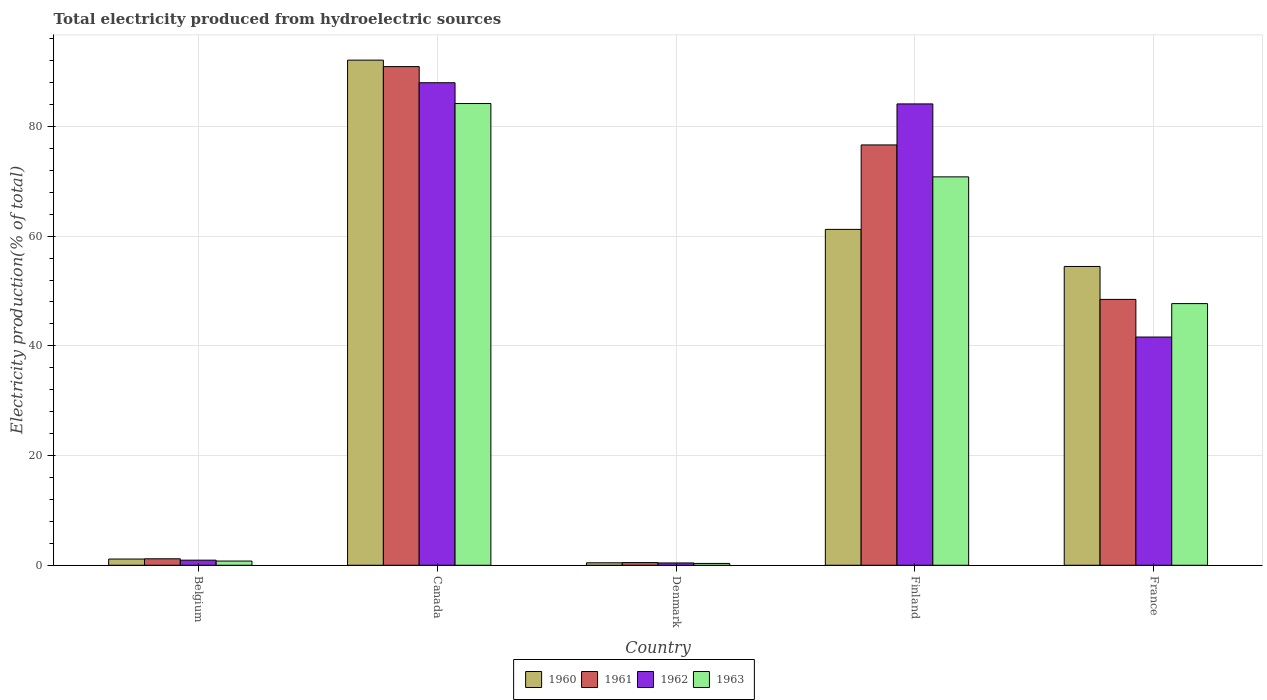How many different coloured bars are there?
Provide a succinct answer. 4. How many groups of bars are there?
Offer a terse response. 5. How many bars are there on the 1st tick from the left?
Offer a terse response. 4. How many bars are there on the 2nd tick from the right?
Offer a very short reply. 4. What is the total electricity produced in 1960 in Belgium?
Give a very brief answer. 1.14. Across all countries, what is the maximum total electricity produced in 1960?
Provide a short and direct response. 92.09. Across all countries, what is the minimum total electricity produced in 1962?
Keep it short and to the point. 0.42. In which country was the total electricity produced in 1960 maximum?
Provide a succinct answer. Canada. What is the total total electricity produced in 1960 in the graph?
Keep it short and to the point. 209.38. What is the difference between the total electricity produced in 1960 in Finland and that in France?
Make the answer very short. 6.76. What is the difference between the total electricity produced in 1963 in Belgium and the total electricity produced in 1962 in Finland?
Offer a very short reply. -83.34. What is the average total electricity produced in 1961 per country?
Ensure brevity in your answer.  43.53. What is the difference between the total electricity produced of/in 1962 and total electricity produced of/in 1963 in Belgium?
Provide a succinct answer. 0.16. What is the ratio of the total electricity produced in 1960 in Denmark to that in Finland?
Your answer should be compact. 0.01. Is the total electricity produced in 1961 in Belgium less than that in Denmark?
Provide a succinct answer. No. Is the difference between the total electricity produced in 1962 in Belgium and Finland greater than the difference between the total electricity produced in 1963 in Belgium and Finland?
Your response must be concise. No. What is the difference between the highest and the second highest total electricity produced in 1960?
Your answer should be compact. 30.86. What is the difference between the highest and the lowest total electricity produced in 1960?
Provide a short and direct response. 91.64. In how many countries, is the total electricity produced in 1960 greater than the average total electricity produced in 1960 taken over all countries?
Make the answer very short. 3. What does the 1st bar from the right in Finland represents?
Provide a succinct answer. 1963. Is it the case that in every country, the sum of the total electricity produced in 1962 and total electricity produced in 1963 is greater than the total electricity produced in 1960?
Your answer should be compact. Yes. How many bars are there?
Provide a succinct answer. 20. How many countries are there in the graph?
Your answer should be very brief. 5. What is the difference between two consecutive major ticks on the Y-axis?
Offer a terse response. 20. Are the values on the major ticks of Y-axis written in scientific E-notation?
Provide a short and direct response. No. Does the graph contain grids?
Your answer should be compact. Yes. Where does the legend appear in the graph?
Ensure brevity in your answer.  Bottom center. What is the title of the graph?
Your answer should be very brief. Total electricity produced from hydroelectric sources. Does "1966" appear as one of the legend labels in the graph?
Offer a terse response. No. What is the Electricity production(% of total) of 1960 in Belgium?
Provide a short and direct response. 1.14. What is the Electricity production(% of total) in 1961 in Belgium?
Keep it short and to the point. 1.18. What is the Electricity production(% of total) of 1962 in Belgium?
Keep it short and to the point. 0.93. What is the Electricity production(% of total) of 1963 in Belgium?
Ensure brevity in your answer.  0.77. What is the Electricity production(% of total) in 1960 in Canada?
Provide a succinct answer. 92.09. What is the Electricity production(% of total) in 1961 in Canada?
Provide a succinct answer. 90.91. What is the Electricity production(% of total) in 1962 in Canada?
Your answer should be very brief. 87.97. What is the Electricity production(% of total) in 1963 in Canada?
Provide a succinct answer. 84.18. What is the Electricity production(% of total) of 1960 in Denmark?
Make the answer very short. 0.45. What is the Electricity production(% of total) of 1961 in Denmark?
Give a very brief answer. 0.49. What is the Electricity production(% of total) in 1962 in Denmark?
Give a very brief answer. 0.42. What is the Electricity production(% of total) of 1963 in Denmark?
Keep it short and to the point. 0.33. What is the Electricity production(% of total) in 1960 in Finland?
Give a very brief answer. 61.23. What is the Electricity production(% of total) in 1961 in Finland?
Your answer should be very brief. 76.63. What is the Electricity production(% of total) of 1962 in Finland?
Offer a very short reply. 84.11. What is the Electricity production(% of total) of 1963 in Finland?
Give a very brief answer. 70.81. What is the Electricity production(% of total) in 1960 in France?
Provide a short and direct response. 54.47. What is the Electricity production(% of total) in 1961 in France?
Your answer should be compact. 48.47. What is the Electricity production(% of total) in 1962 in France?
Ensure brevity in your answer.  41.61. What is the Electricity production(% of total) in 1963 in France?
Your response must be concise. 47.7. Across all countries, what is the maximum Electricity production(% of total) of 1960?
Your response must be concise. 92.09. Across all countries, what is the maximum Electricity production(% of total) of 1961?
Ensure brevity in your answer.  90.91. Across all countries, what is the maximum Electricity production(% of total) of 1962?
Your response must be concise. 87.97. Across all countries, what is the maximum Electricity production(% of total) in 1963?
Make the answer very short. 84.18. Across all countries, what is the minimum Electricity production(% of total) of 1960?
Give a very brief answer. 0.45. Across all countries, what is the minimum Electricity production(% of total) in 1961?
Offer a terse response. 0.49. Across all countries, what is the minimum Electricity production(% of total) in 1962?
Provide a succinct answer. 0.42. Across all countries, what is the minimum Electricity production(% of total) of 1963?
Offer a very short reply. 0.33. What is the total Electricity production(% of total) of 1960 in the graph?
Provide a short and direct response. 209.38. What is the total Electricity production(% of total) of 1961 in the graph?
Offer a terse response. 217.67. What is the total Electricity production(% of total) of 1962 in the graph?
Give a very brief answer. 215.03. What is the total Electricity production(% of total) in 1963 in the graph?
Provide a succinct answer. 203.79. What is the difference between the Electricity production(% of total) in 1960 in Belgium and that in Canada?
Keep it short and to the point. -90.95. What is the difference between the Electricity production(% of total) in 1961 in Belgium and that in Canada?
Offer a terse response. -89.73. What is the difference between the Electricity production(% of total) of 1962 in Belgium and that in Canada?
Your answer should be compact. -87.04. What is the difference between the Electricity production(% of total) in 1963 in Belgium and that in Canada?
Your answer should be very brief. -83.41. What is the difference between the Electricity production(% of total) of 1960 in Belgium and that in Denmark?
Make the answer very short. 0.68. What is the difference between the Electricity production(% of total) of 1961 in Belgium and that in Denmark?
Keep it short and to the point. 0.69. What is the difference between the Electricity production(% of total) in 1962 in Belgium and that in Denmark?
Keep it short and to the point. 0.51. What is the difference between the Electricity production(% of total) of 1963 in Belgium and that in Denmark?
Your answer should be compact. 0.43. What is the difference between the Electricity production(% of total) of 1960 in Belgium and that in Finland?
Your answer should be compact. -60.1. What is the difference between the Electricity production(% of total) of 1961 in Belgium and that in Finland?
Give a very brief answer. -75.45. What is the difference between the Electricity production(% of total) in 1962 in Belgium and that in Finland?
Give a very brief answer. -83.18. What is the difference between the Electricity production(% of total) in 1963 in Belgium and that in Finland?
Your answer should be very brief. -70.04. What is the difference between the Electricity production(% of total) in 1960 in Belgium and that in France?
Keep it short and to the point. -53.34. What is the difference between the Electricity production(% of total) in 1961 in Belgium and that in France?
Offer a very short reply. -47.29. What is the difference between the Electricity production(% of total) in 1962 in Belgium and that in France?
Make the answer very short. -40.68. What is the difference between the Electricity production(% of total) of 1963 in Belgium and that in France?
Offer a very short reply. -46.94. What is the difference between the Electricity production(% of total) of 1960 in Canada and that in Denmark?
Your answer should be compact. 91.64. What is the difference between the Electricity production(% of total) in 1961 in Canada and that in Denmark?
Offer a very short reply. 90.42. What is the difference between the Electricity production(% of total) of 1962 in Canada and that in Denmark?
Your answer should be compact. 87.55. What is the difference between the Electricity production(% of total) in 1963 in Canada and that in Denmark?
Your response must be concise. 83.84. What is the difference between the Electricity production(% of total) of 1960 in Canada and that in Finland?
Your answer should be compact. 30.86. What is the difference between the Electricity production(% of total) in 1961 in Canada and that in Finland?
Give a very brief answer. 14.28. What is the difference between the Electricity production(% of total) in 1962 in Canada and that in Finland?
Your answer should be compact. 3.86. What is the difference between the Electricity production(% of total) of 1963 in Canada and that in Finland?
Offer a terse response. 13.37. What is the difference between the Electricity production(% of total) of 1960 in Canada and that in France?
Your response must be concise. 37.62. What is the difference between the Electricity production(% of total) of 1961 in Canada and that in France?
Make the answer very short. 42.44. What is the difference between the Electricity production(% of total) of 1962 in Canada and that in France?
Offer a terse response. 46.36. What is the difference between the Electricity production(% of total) of 1963 in Canada and that in France?
Give a very brief answer. 36.48. What is the difference between the Electricity production(% of total) of 1960 in Denmark and that in Finland?
Your answer should be very brief. -60.78. What is the difference between the Electricity production(% of total) in 1961 in Denmark and that in Finland?
Your answer should be compact. -76.14. What is the difference between the Electricity production(% of total) of 1962 in Denmark and that in Finland?
Provide a short and direct response. -83.69. What is the difference between the Electricity production(% of total) of 1963 in Denmark and that in Finland?
Ensure brevity in your answer.  -70.47. What is the difference between the Electricity production(% of total) in 1960 in Denmark and that in France?
Provide a short and direct response. -54.02. What is the difference between the Electricity production(% of total) of 1961 in Denmark and that in France?
Provide a short and direct response. -47.98. What is the difference between the Electricity production(% of total) of 1962 in Denmark and that in France?
Provide a succinct answer. -41.18. What is the difference between the Electricity production(% of total) in 1963 in Denmark and that in France?
Your answer should be very brief. -47.37. What is the difference between the Electricity production(% of total) of 1960 in Finland and that in France?
Provide a short and direct response. 6.76. What is the difference between the Electricity production(% of total) of 1961 in Finland and that in France?
Give a very brief answer. 28.16. What is the difference between the Electricity production(% of total) in 1962 in Finland and that in France?
Provide a short and direct response. 42.5. What is the difference between the Electricity production(% of total) in 1963 in Finland and that in France?
Keep it short and to the point. 23.11. What is the difference between the Electricity production(% of total) of 1960 in Belgium and the Electricity production(% of total) of 1961 in Canada?
Offer a very short reply. -89.78. What is the difference between the Electricity production(% of total) of 1960 in Belgium and the Electricity production(% of total) of 1962 in Canada?
Offer a very short reply. -86.83. What is the difference between the Electricity production(% of total) of 1960 in Belgium and the Electricity production(% of total) of 1963 in Canada?
Ensure brevity in your answer.  -83.04. What is the difference between the Electricity production(% of total) in 1961 in Belgium and the Electricity production(% of total) in 1962 in Canada?
Ensure brevity in your answer.  -86.79. What is the difference between the Electricity production(% of total) of 1961 in Belgium and the Electricity production(% of total) of 1963 in Canada?
Offer a terse response. -83. What is the difference between the Electricity production(% of total) of 1962 in Belgium and the Electricity production(% of total) of 1963 in Canada?
Your response must be concise. -83.25. What is the difference between the Electricity production(% of total) in 1960 in Belgium and the Electricity production(% of total) in 1961 in Denmark?
Your answer should be compact. 0.65. What is the difference between the Electricity production(% of total) in 1960 in Belgium and the Electricity production(% of total) in 1962 in Denmark?
Provide a short and direct response. 0.71. What is the difference between the Electricity production(% of total) in 1960 in Belgium and the Electricity production(% of total) in 1963 in Denmark?
Your response must be concise. 0.8. What is the difference between the Electricity production(% of total) of 1961 in Belgium and the Electricity production(% of total) of 1962 in Denmark?
Provide a succinct answer. 0.76. What is the difference between the Electricity production(% of total) of 1961 in Belgium and the Electricity production(% of total) of 1963 in Denmark?
Keep it short and to the point. 0.84. What is the difference between the Electricity production(% of total) of 1962 in Belgium and the Electricity production(% of total) of 1963 in Denmark?
Your answer should be very brief. 0.59. What is the difference between the Electricity production(% of total) in 1960 in Belgium and the Electricity production(% of total) in 1961 in Finland?
Keep it short and to the point. -75.49. What is the difference between the Electricity production(% of total) of 1960 in Belgium and the Electricity production(% of total) of 1962 in Finland?
Your answer should be compact. -82.97. What is the difference between the Electricity production(% of total) of 1960 in Belgium and the Electricity production(% of total) of 1963 in Finland?
Offer a terse response. -69.67. What is the difference between the Electricity production(% of total) in 1961 in Belgium and the Electricity production(% of total) in 1962 in Finland?
Your response must be concise. -82.93. What is the difference between the Electricity production(% of total) in 1961 in Belgium and the Electricity production(% of total) in 1963 in Finland?
Your answer should be compact. -69.63. What is the difference between the Electricity production(% of total) of 1962 in Belgium and the Electricity production(% of total) of 1963 in Finland?
Keep it short and to the point. -69.88. What is the difference between the Electricity production(% of total) of 1960 in Belgium and the Electricity production(% of total) of 1961 in France?
Make the answer very short. -47.33. What is the difference between the Electricity production(% of total) in 1960 in Belgium and the Electricity production(% of total) in 1962 in France?
Ensure brevity in your answer.  -40.47. What is the difference between the Electricity production(% of total) in 1960 in Belgium and the Electricity production(% of total) in 1963 in France?
Provide a succinct answer. -46.57. What is the difference between the Electricity production(% of total) of 1961 in Belgium and the Electricity production(% of total) of 1962 in France?
Ensure brevity in your answer.  -40.43. What is the difference between the Electricity production(% of total) in 1961 in Belgium and the Electricity production(% of total) in 1963 in France?
Make the answer very short. -46.52. What is the difference between the Electricity production(% of total) in 1962 in Belgium and the Electricity production(% of total) in 1963 in France?
Provide a succinct answer. -46.77. What is the difference between the Electricity production(% of total) of 1960 in Canada and the Electricity production(% of total) of 1961 in Denmark?
Your response must be concise. 91.6. What is the difference between the Electricity production(% of total) of 1960 in Canada and the Electricity production(% of total) of 1962 in Denmark?
Offer a terse response. 91.67. What is the difference between the Electricity production(% of total) of 1960 in Canada and the Electricity production(% of total) of 1963 in Denmark?
Your answer should be compact. 91.75. What is the difference between the Electricity production(% of total) of 1961 in Canada and the Electricity production(% of total) of 1962 in Denmark?
Ensure brevity in your answer.  90.49. What is the difference between the Electricity production(% of total) of 1961 in Canada and the Electricity production(% of total) of 1963 in Denmark?
Provide a succinct answer. 90.58. What is the difference between the Electricity production(% of total) in 1962 in Canada and the Electricity production(% of total) in 1963 in Denmark?
Ensure brevity in your answer.  87.63. What is the difference between the Electricity production(% of total) in 1960 in Canada and the Electricity production(% of total) in 1961 in Finland?
Your answer should be very brief. 15.46. What is the difference between the Electricity production(% of total) in 1960 in Canada and the Electricity production(% of total) in 1962 in Finland?
Provide a short and direct response. 7.98. What is the difference between the Electricity production(% of total) of 1960 in Canada and the Electricity production(% of total) of 1963 in Finland?
Provide a succinct answer. 21.28. What is the difference between the Electricity production(% of total) in 1961 in Canada and the Electricity production(% of total) in 1962 in Finland?
Your response must be concise. 6.8. What is the difference between the Electricity production(% of total) in 1961 in Canada and the Electricity production(% of total) in 1963 in Finland?
Offer a terse response. 20.1. What is the difference between the Electricity production(% of total) in 1962 in Canada and the Electricity production(% of total) in 1963 in Finland?
Provide a short and direct response. 17.16. What is the difference between the Electricity production(% of total) of 1960 in Canada and the Electricity production(% of total) of 1961 in France?
Offer a terse response. 43.62. What is the difference between the Electricity production(% of total) in 1960 in Canada and the Electricity production(% of total) in 1962 in France?
Your response must be concise. 50.48. What is the difference between the Electricity production(% of total) of 1960 in Canada and the Electricity production(% of total) of 1963 in France?
Your answer should be very brief. 44.39. What is the difference between the Electricity production(% of total) in 1961 in Canada and the Electricity production(% of total) in 1962 in France?
Give a very brief answer. 49.3. What is the difference between the Electricity production(% of total) in 1961 in Canada and the Electricity production(% of total) in 1963 in France?
Make the answer very short. 43.21. What is the difference between the Electricity production(% of total) in 1962 in Canada and the Electricity production(% of total) in 1963 in France?
Make the answer very short. 40.27. What is the difference between the Electricity production(% of total) of 1960 in Denmark and the Electricity production(% of total) of 1961 in Finland?
Provide a succinct answer. -76.18. What is the difference between the Electricity production(% of total) of 1960 in Denmark and the Electricity production(% of total) of 1962 in Finland?
Give a very brief answer. -83.66. What is the difference between the Electricity production(% of total) in 1960 in Denmark and the Electricity production(% of total) in 1963 in Finland?
Keep it short and to the point. -70.36. What is the difference between the Electricity production(% of total) in 1961 in Denmark and the Electricity production(% of total) in 1962 in Finland?
Give a very brief answer. -83.62. What is the difference between the Electricity production(% of total) of 1961 in Denmark and the Electricity production(% of total) of 1963 in Finland?
Your answer should be very brief. -70.32. What is the difference between the Electricity production(% of total) of 1962 in Denmark and the Electricity production(% of total) of 1963 in Finland?
Provide a succinct answer. -70.39. What is the difference between the Electricity production(% of total) in 1960 in Denmark and the Electricity production(% of total) in 1961 in France?
Give a very brief answer. -48.02. What is the difference between the Electricity production(% of total) of 1960 in Denmark and the Electricity production(% of total) of 1962 in France?
Make the answer very short. -41.15. What is the difference between the Electricity production(% of total) of 1960 in Denmark and the Electricity production(% of total) of 1963 in France?
Give a very brief answer. -47.25. What is the difference between the Electricity production(% of total) in 1961 in Denmark and the Electricity production(% of total) in 1962 in France?
Your answer should be compact. -41.12. What is the difference between the Electricity production(% of total) of 1961 in Denmark and the Electricity production(% of total) of 1963 in France?
Provide a short and direct response. -47.21. What is the difference between the Electricity production(% of total) of 1962 in Denmark and the Electricity production(% of total) of 1963 in France?
Provide a succinct answer. -47.28. What is the difference between the Electricity production(% of total) in 1960 in Finland and the Electricity production(% of total) in 1961 in France?
Keep it short and to the point. 12.76. What is the difference between the Electricity production(% of total) of 1960 in Finland and the Electricity production(% of total) of 1962 in France?
Provide a succinct answer. 19.63. What is the difference between the Electricity production(% of total) in 1960 in Finland and the Electricity production(% of total) in 1963 in France?
Your answer should be very brief. 13.53. What is the difference between the Electricity production(% of total) of 1961 in Finland and the Electricity production(% of total) of 1962 in France?
Ensure brevity in your answer.  35.02. What is the difference between the Electricity production(% of total) of 1961 in Finland and the Electricity production(% of total) of 1963 in France?
Provide a succinct answer. 28.93. What is the difference between the Electricity production(% of total) in 1962 in Finland and the Electricity production(% of total) in 1963 in France?
Offer a very short reply. 36.41. What is the average Electricity production(% of total) in 1960 per country?
Keep it short and to the point. 41.88. What is the average Electricity production(% of total) of 1961 per country?
Ensure brevity in your answer.  43.53. What is the average Electricity production(% of total) of 1962 per country?
Give a very brief answer. 43.01. What is the average Electricity production(% of total) in 1963 per country?
Ensure brevity in your answer.  40.76. What is the difference between the Electricity production(% of total) of 1960 and Electricity production(% of total) of 1961 in Belgium?
Your answer should be very brief. -0.04. What is the difference between the Electricity production(% of total) of 1960 and Electricity production(% of total) of 1962 in Belgium?
Give a very brief answer. 0.21. What is the difference between the Electricity production(% of total) of 1960 and Electricity production(% of total) of 1963 in Belgium?
Make the answer very short. 0.37. What is the difference between the Electricity production(% of total) in 1961 and Electricity production(% of total) in 1962 in Belgium?
Offer a terse response. 0.25. What is the difference between the Electricity production(% of total) in 1961 and Electricity production(% of total) in 1963 in Belgium?
Provide a short and direct response. 0.41. What is the difference between the Electricity production(% of total) in 1962 and Electricity production(% of total) in 1963 in Belgium?
Your answer should be compact. 0.16. What is the difference between the Electricity production(% of total) in 1960 and Electricity production(% of total) in 1961 in Canada?
Make the answer very short. 1.18. What is the difference between the Electricity production(% of total) in 1960 and Electricity production(% of total) in 1962 in Canada?
Offer a terse response. 4.12. What is the difference between the Electricity production(% of total) in 1960 and Electricity production(% of total) in 1963 in Canada?
Ensure brevity in your answer.  7.91. What is the difference between the Electricity production(% of total) in 1961 and Electricity production(% of total) in 1962 in Canada?
Provide a succinct answer. 2.94. What is the difference between the Electricity production(% of total) of 1961 and Electricity production(% of total) of 1963 in Canada?
Make the answer very short. 6.73. What is the difference between the Electricity production(% of total) of 1962 and Electricity production(% of total) of 1963 in Canada?
Your response must be concise. 3.79. What is the difference between the Electricity production(% of total) in 1960 and Electricity production(% of total) in 1961 in Denmark?
Give a very brief answer. -0.04. What is the difference between the Electricity production(% of total) of 1960 and Electricity production(% of total) of 1962 in Denmark?
Give a very brief answer. 0.03. What is the difference between the Electricity production(% of total) in 1960 and Electricity production(% of total) in 1963 in Denmark?
Your response must be concise. 0.12. What is the difference between the Electricity production(% of total) of 1961 and Electricity production(% of total) of 1962 in Denmark?
Your answer should be compact. 0.07. What is the difference between the Electricity production(% of total) of 1961 and Electricity production(% of total) of 1963 in Denmark?
Give a very brief answer. 0.15. What is the difference between the Electricity production(% of total) in 1962 and Electricity production(% of total) in 1963 in Denmark?
Give a very brief answer. 0.09. What is the difference between the Electricity production(% of total) of 1960 and Electricity production(% of total) of 1961 in Finland?
Make the answer very short. -15.4. What is the difference between the Electricity production(% of total) in 1960 and Electricity production(% of total) in 1962 in Finland?
Offer a terse response. -22.88. What is the difference between the Electricity production(% of total) of 1960 and Electricity production(% of total) of 1963 in Finland?
Your answer should be compact. -9.58. What is the difference between the Electricity production(% of total) of 1961 and Electricity production(% of total) of 1962 in Finland?
Give a very brief answer. -7.48. What is the difference between the Electricity production(% of total) of 1961 and Electricity production(% of total) of 1963 in Finland?
Make the answer very short. 5.82. What is the difference between the Electricity production(% of total) in 1962 and Electricity production(% of total) in 1963 in Finland?
Give a very brief answer. 13.3. What is the difference between the Electricity production(% of total) of 1960 and Electricity production(% of total) of 1961 in France?
Give a very brief answer. 6.01. What is the difference between the Electricity production(% of total) in 1960 and Electricity production(% of total) in 1962 in France?
Give a very brief answer. 12.87. What is the difference between the Electricity production(% of total) in 1960 and Electricity production(% of total) in 1963 in France?
Provide a succinct answer. 6.77. What is the difference between the Electricity production(% of total) of 1961 and Electricity production(% of total) of 1962 in France?
Ensure brevity in your answer.  6.86. What is the difference between the Electricity production(% of total) in 1961 and Electricity production(% of total) in 1963 in France?
Your answer should be compact. 0.77. What is the difference between the Electricity production(% of total) of 1962 and Electricity production(% of total) of 1963 in France?
Your response must be concise. -6.1. What is the ratio of the Electricity production(% of total) of 1960 in Belgium to that in Canada?
Offer a very short reply. 0.01. What is the ratio of the Electricity production(% of total) of 1961 in Belgium to that in Canada?
Keep it short and to the point. 0.01. What is the ratio of the Electricity production(% of total) of 1962 in Belgium to that in Canada?
Give a very brief answer. 0.01. What is the ratio of the Electricity production(% of total) in 1963 in Belgium to that in Canada?
Your answer should be compact. 0.01. What is the ratio of the Electricity production(% of total) in 1960 in Belgium to that in Denmark?
Provide a short and direct response. 2.52. What is the ratio of the Electricity production(% of total) in 1961 in Belgium to that in Denmark?
Provide a short and direct response. 2.41. What is the ratio of the Electricity production(% of total) of 1962 in Belgium to that in Denmark?
Offer a very short reply. 2.21. What is the ratio of the Electricity production(% of total) of 1963 in Belgium to that in Denmark?
Provide a succinct answer. 2.29. What is the ratio of the Electricity production(% of total) in 1960 in Belgium to that in Finland?
Your response must be concise. 0.02. What is the ratio of the Electricity production(% of total) of 1961 in Belgium to that in Finland?
Make the answer very short. 0.02. What is the ratio of the Electricity production(% of total) of 1962 in Belgium to that in Finland?
Provide a short and direct response. 0.01. What is the ratio of the Electricity production(% of total) in 1963 in Belgium to that in Finland?
Give a very brief answer. 0.01. What is the ratio of the Electricity production(% of total) of 1960 in Belgium to that in France?
Your response must be concise. 0.02. What is the ratio of the Electricity production(% of total) of 1961 in Belgium to that in France?
Give a very brief answer. 0.02. What is the ratio of the Electricity production(% of total) in 1962 in Belgium to that in France?
Provide a succinct answer. 0.02. What is the ratio of the Electricity production(% of total) in 1963 in Belgium to that in France?
Provide a succinct answer. 0.02. What is the ratio of the Electricity production(% of total) in 1960 in Canada to that in Denmark?
Ensure brevity in your answer.  204.07. What is the ratio of the Electricity production(% of total) of 1961 in Canada to that in Denmark?
Ensure brevity in your answer.  185.88. What is the ratio of the Electricity production(% of total) in 1962 in Canada to that in Denmark?
Give a very brief answer. 208.99. What is the ratio of the Electricity production(% of total) of 1963 in Canada to that in Denmark?
Your answer should be compact. 251.69. What is the ratio of the Electricity production(% of total) in 1960 in Canada to that in Finland?
Your response must be concise. 1.5. What is the ratio of the Electricity production(% of total) of 1961 in Canada to that in Finland?
Provide a short and direct response. 1.19. What is the ratio of the Electricity production(% of total) in 1962 in Canada to that in Finland?
Offer a very short reply. 1.05. What is the ratio of the Electricity production(% of total) in 1963 in Canada to that in Finland?
Ensure brevity in your answer.  1.19. What is the ratio of the Electricity production(% of total) of 1960 in Canada to that in France?
Ensure brevity in your answer.  1.69. What is the ratio of the Electricity production(% of total) of 1961 in Canada to that in France?
Make the answer very short. 1.88. What is the ratio of the Electricity production(% of total) in 1962 in Canada to that in France?
Keep it short and to the point. 2.11. What is the ratio of the Electricity production(% of total) in 1963 in Canada to that in France?
Your response must be concise. 1.76. What is the ratio of the Electricity production(% of total) of 1960 in Denmark to that in Finland?
Give a very brief answer. 0.01. What is the ratio of the Electricity production(% of total) of 1961 in Denmark to that in Finland?
Make the answer very short. 0.01. What is the ratio of the Electricity production(% of total) of 1962 in Denmark to that in Finland?
Your response must be concise. 0.01. What is the ratio of the Electricity production(% of total) in 1963 in Denmark to that in Finland?
Your answer should be very brief. 0. What is the ratio of the Electricity production(% of total) in 1960 in Denmark to that in France?
Your response must be concise. 0.01. What is the ratio of the Electricity production(% of total) of 1961 in Denmark to that in France?
Your answer should be very brief. 0.01. What is the ratio of the Electricity production(% of total) of 1962 in Denmark to that in France?
Your answer should be very brief. 0.01. What is the ratio of the Electricity production(% of total) in 1963 in Denmark to that in France?
Ensure brevity in your answer.  0.01. What is the ratio of the Electricity production(% of total) in 1960 in Finland to that in France?
Offer a very short reply. 1.12. What is the ratio of the Electricity production(% of total) in 1961 in Finland to that in France?
Provide a succinct answer. 1.58. What is the ratio of the Electricity production(% of total) of 1962 in Finland to that in France?
Your answer should be very brief. 2.02. What is the ratio of the Electricity production(% of total) of 1963 in Finland to that in France?
Your answer should be very brief. 1.48. What is the difference between the highest and the second highest Electricity production(% of total) in 1960?
Provide a short and direct response. 30.86. What is the difference between the highest and the second highest Electricity production(% of total) in 1961?
Ensure brevity in your answer.  14.28. What is the difference between the highest and the second highest Electricity production(% of total) in 1962?
Your response must be concise. 3.86. What is the difference between the highest and the second highest Electricity production(% of total) in 1963?
Your answer should be very brief. 13.37. What is the difference between the highest and the lowest Electricity production(% of total) in 1960?
Keep it short and to the point. 91.64. What is the difference between the highest and the lowest Electricity production(% of total) in 1961?
Keep it short and to the point. 90.42. What is the difference between the highest and the lowest Electricity production(% of total) in 1962?
Offer a very short reply. 87.55. What is the difference between the highest and the lowest Electricity production(% of total) of 1963?
Make the answer very short. 83.84. 